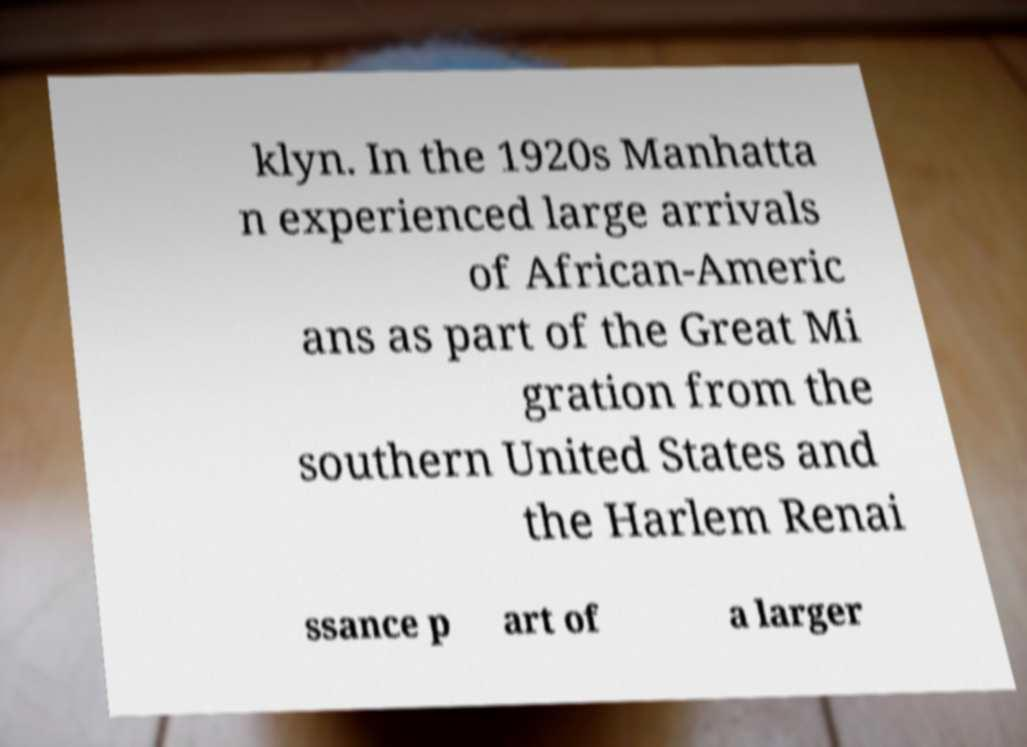Can you read and provide the text displayed in the image?This photo seems to have some interesting text. Can you extract and type it out for me? klyn. In the 1920s Manhatta n experienced large arrivals of African-Americ ans as part of the Great Mi gration from the southern United States and the Harlem Renai ssance p art of a larger 